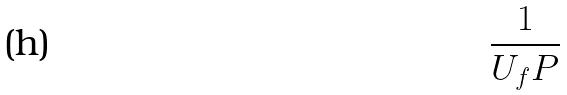Convert formula to latex. <formula><loc_0><loc_0><loc_500><loc_500>\frac { 1 } { U _ { f } P }</formula> 